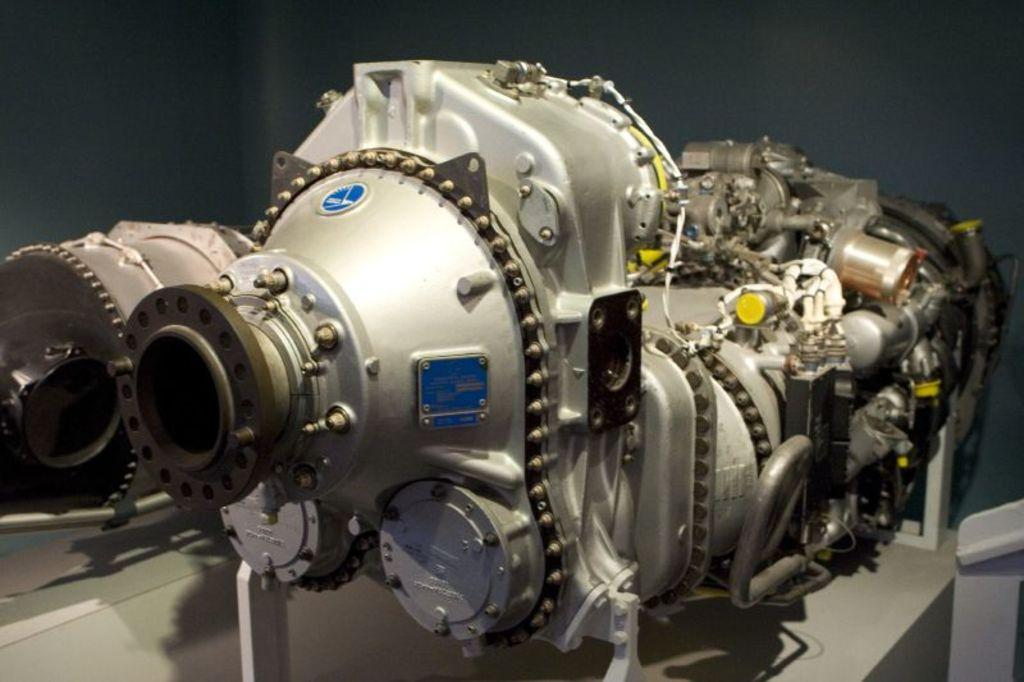What is the main subject in the image? There is a machine in the image. Can you describe the setting of the image? There is a wall in the background of the image. What type of organization is depicted in the image? There is no organization depicted in the image; it features a machine and a wall. Can you see any waves in the image? There are no waves present in the image. 